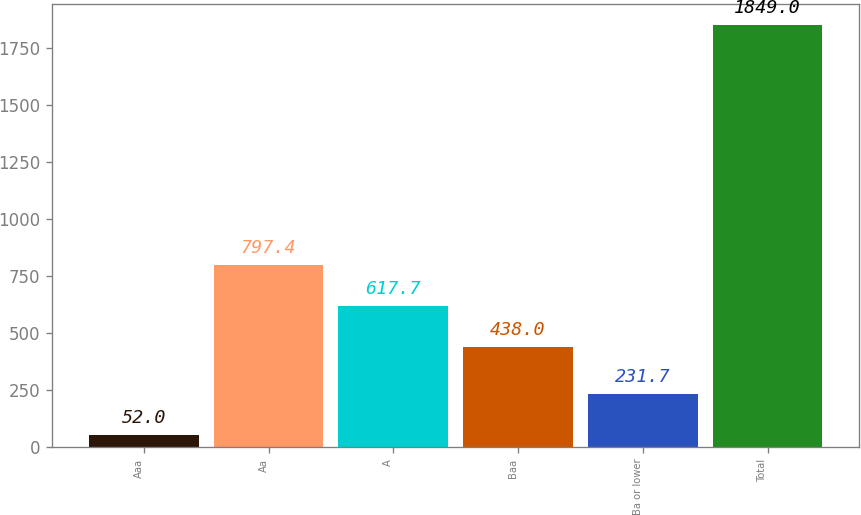Convert chart to OTSL. <chart><loc_0><loc_0><loc_500><loc_500><bar_chart><fcel>Aaa<fcel>Aa<fcel>A<fcel>Baa<fcel>Ba or lower<fcel>Total<nl><fcel>52<fcel>797.4<fcel>617.7<fcel>438<fcel>231.7<fcel>1849<nl></chart> 